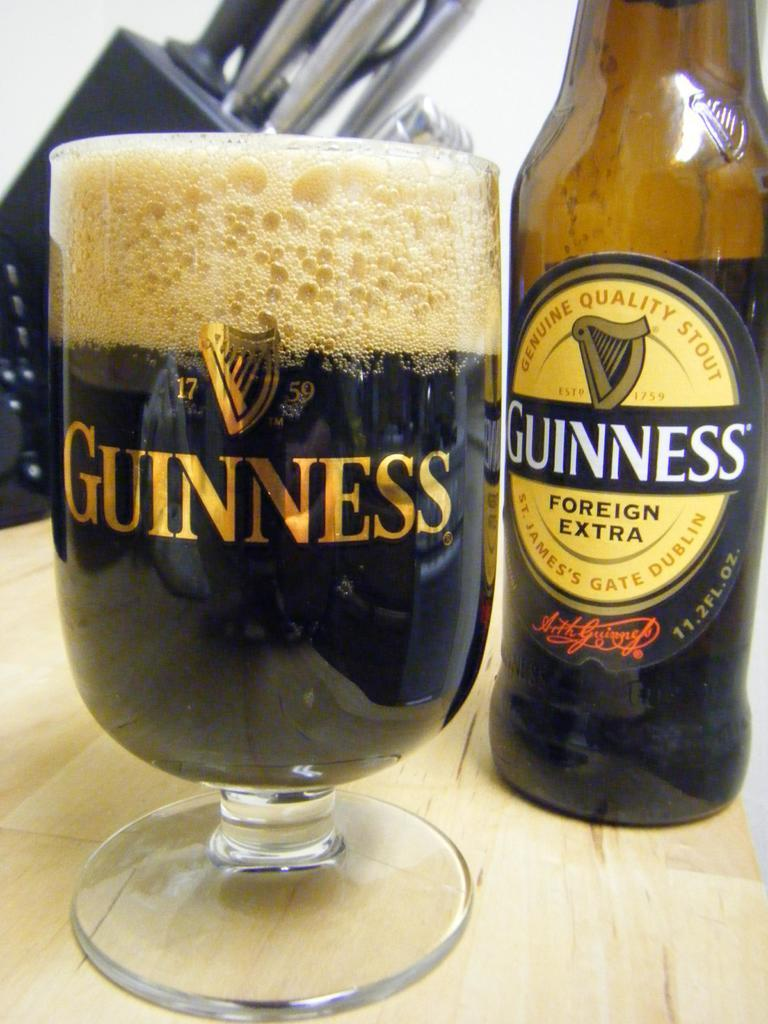What is in the image that is related to a beverage? There is a bottle in the image, and it is labelled with "Guinness Foreign Extra." What else can be seen in the image related to the beverage? There is a glass in the image, and it contains a drink. How many sticks are used to stir the drink in the glass? There are no sticks visible in the image, and therefore no stirring is taking place. 